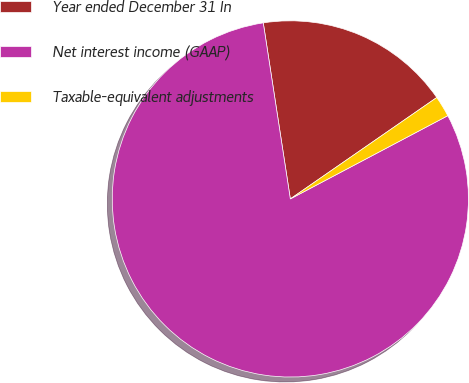<chart> <loc_0><loc_0><loc_500><loc_500><pie_chart><fcel>Year ended December 31 In<fcel>Net interest income (GAAP)<fcel>Taxable-equivalent adjustments<nl><fcel>17.79%<fcel>80.32%<fcel>1.9%<nl></chart> 